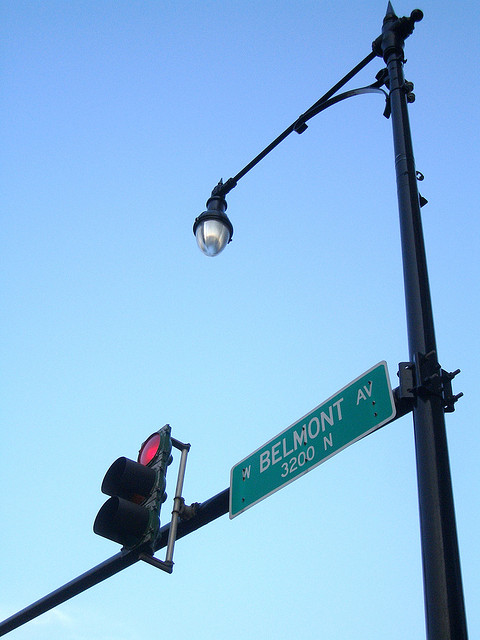Please transcribe the text information in this image. BELMONT W AV 3200 N 